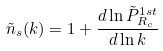<formula> <loc_0><loc_0><loc_500><loc_500>\tilde { n } _ { s } ( k ) = 1 + \frac { d \ln \tilde { P } ^ { 1 s t } _ { R _ { c } } } { d \ln k }</formula> 